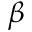Convert formula to latex. <formula><loc_0><loc_0><loc_500><loc_500>\beta</formula> 